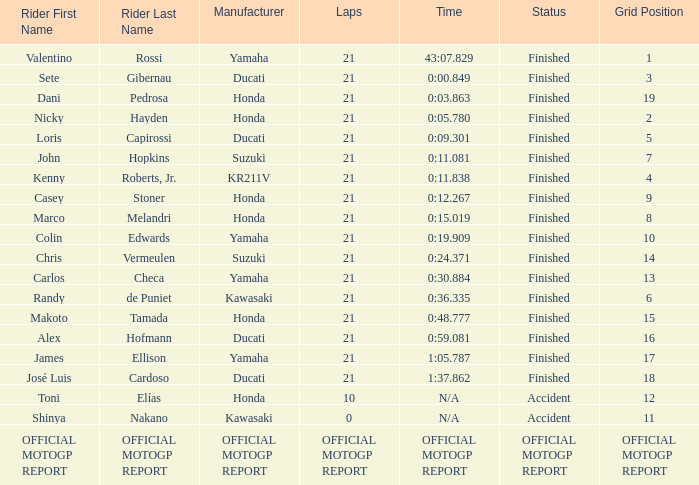What was the amount of laps for the vehicle manufactured by honda with a grid of 9? 21.0. 